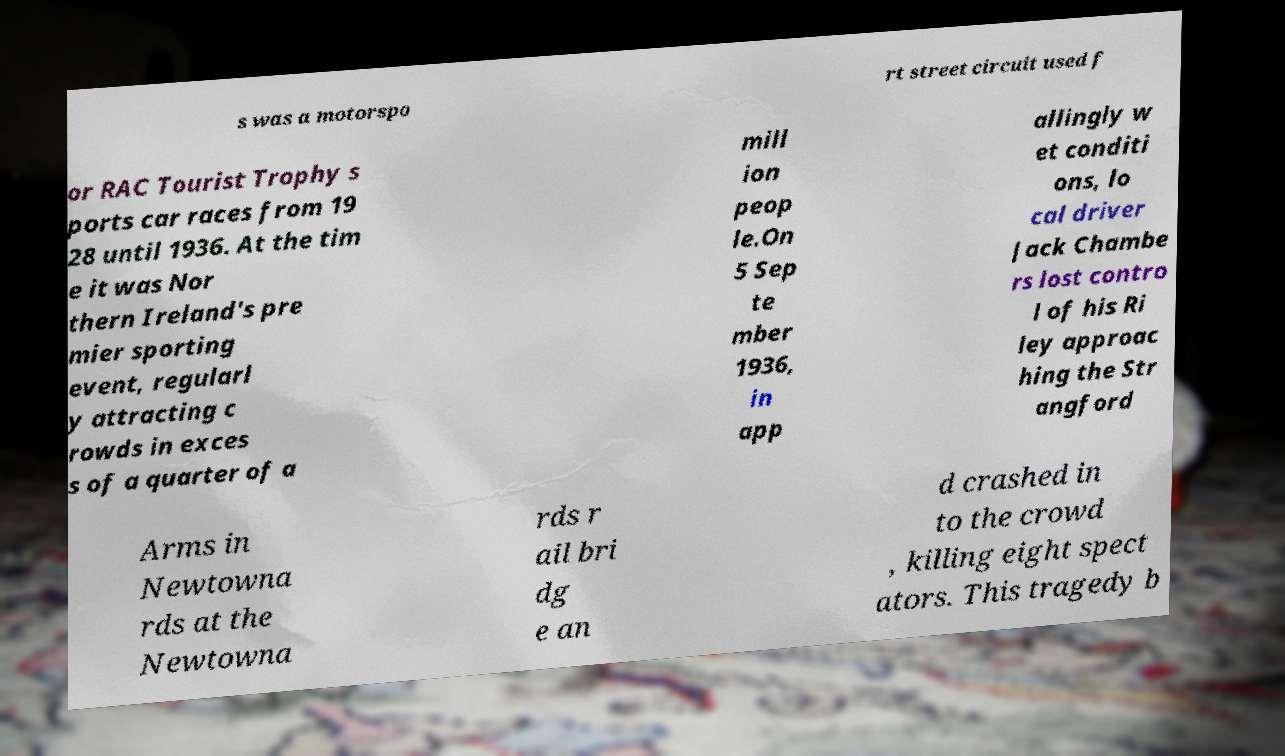There's text embedded in this image that I need extracted. Can you transcribe it verbatim? s was a motorspo rt street circuit used f or RAC Tourist Trophy s ports car races from 19 28 until 1936. At the tim e it was Nor thern Ireland's pre mier sporting event, regularl y attracting c rowds in exces s of a quarter of a mill ion peop le.On 5 Sep te mber 1936, in app allingly w et conditi ons, lo cal driver Jack Chambe rs lost contro l of his Ri ley approac hing the Str angford Arms in Newtowna rds at the Newtowna rds r ail bri dg e an d crashed in to the crowd , killing eight spect ators. This tragedy b 